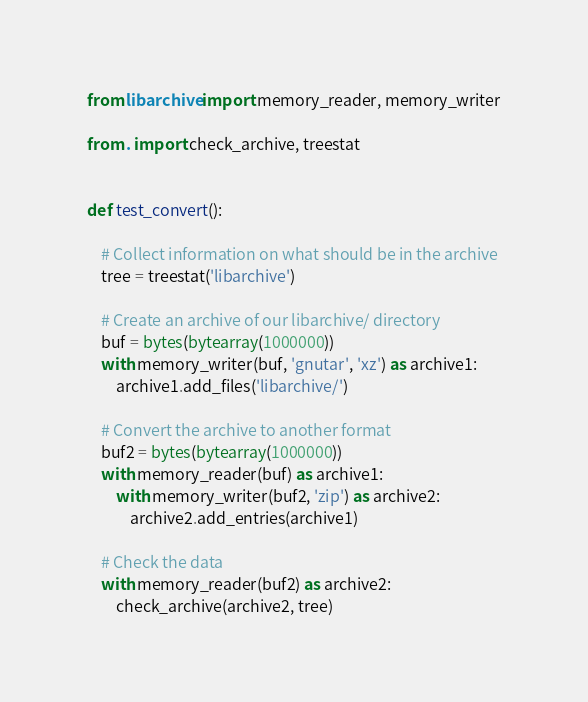Convert code to text. <code><loc_0><loc_0><loc_500><loc_500><_Python_>from libarchive import memory_reader, memory_writer

from . import check_archive, treestat


def test_convert():

    # Collect information on what should be in the archive
    tree = treestat('libarchive')

    # Create an archive of our libarchive/ directory
    buf = bytes(bytearray(1000000))
    with memory_writer(buf, 'gnutar', 'xz') as archive1:
        archive1.add_files('libarchive/')

    # Convert the archive to another format
    buf2 = bytes(bytearray(1000000))
    with memory_reader(buf) as archive1:
        with memory_writer(buf2, 'zip') as archive2:
            archive2.add_entries(archive1)

    # Check the data
    with memory_reader(buf2) as archive2:
        check_archive(archive2, tree)
</code> 